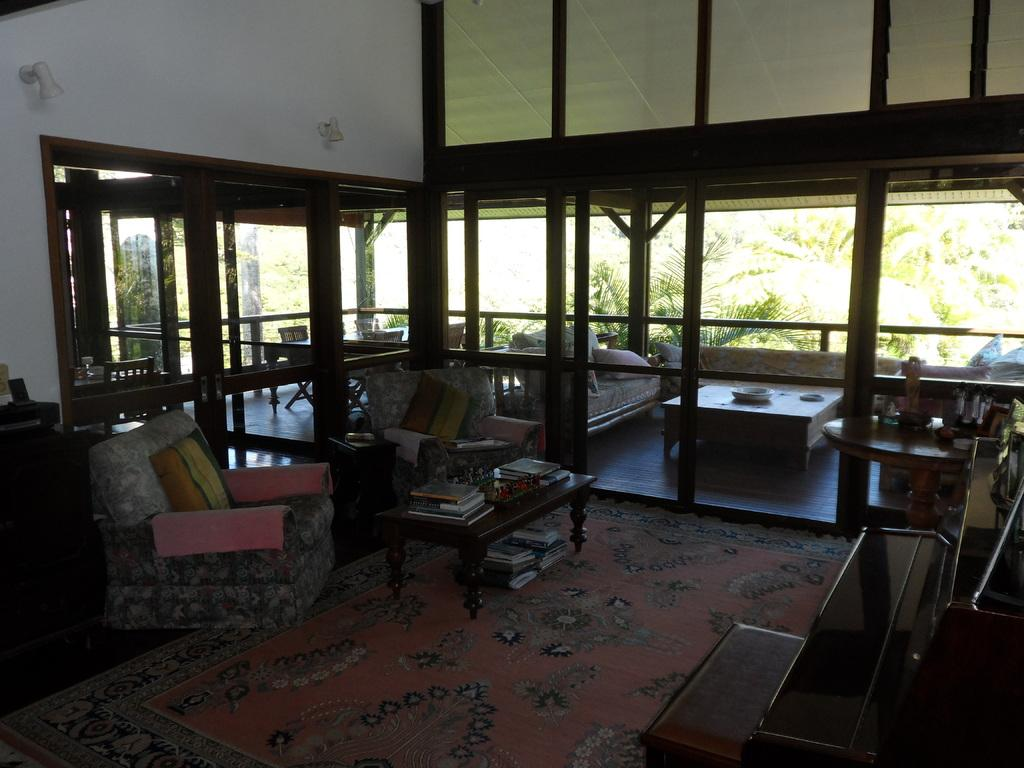What type of furniture is present in the image? There is a chair and a couch in the image. What can be seen on the chair in the image? There is a pillow on the chair in the image. What objects are on the table in the image? There are books on the table in the image. What type of beast can be seen roaming the market in the image? There is no market or beast present in the image; it only features a chair, a couch, a pillow, and books on a table. 